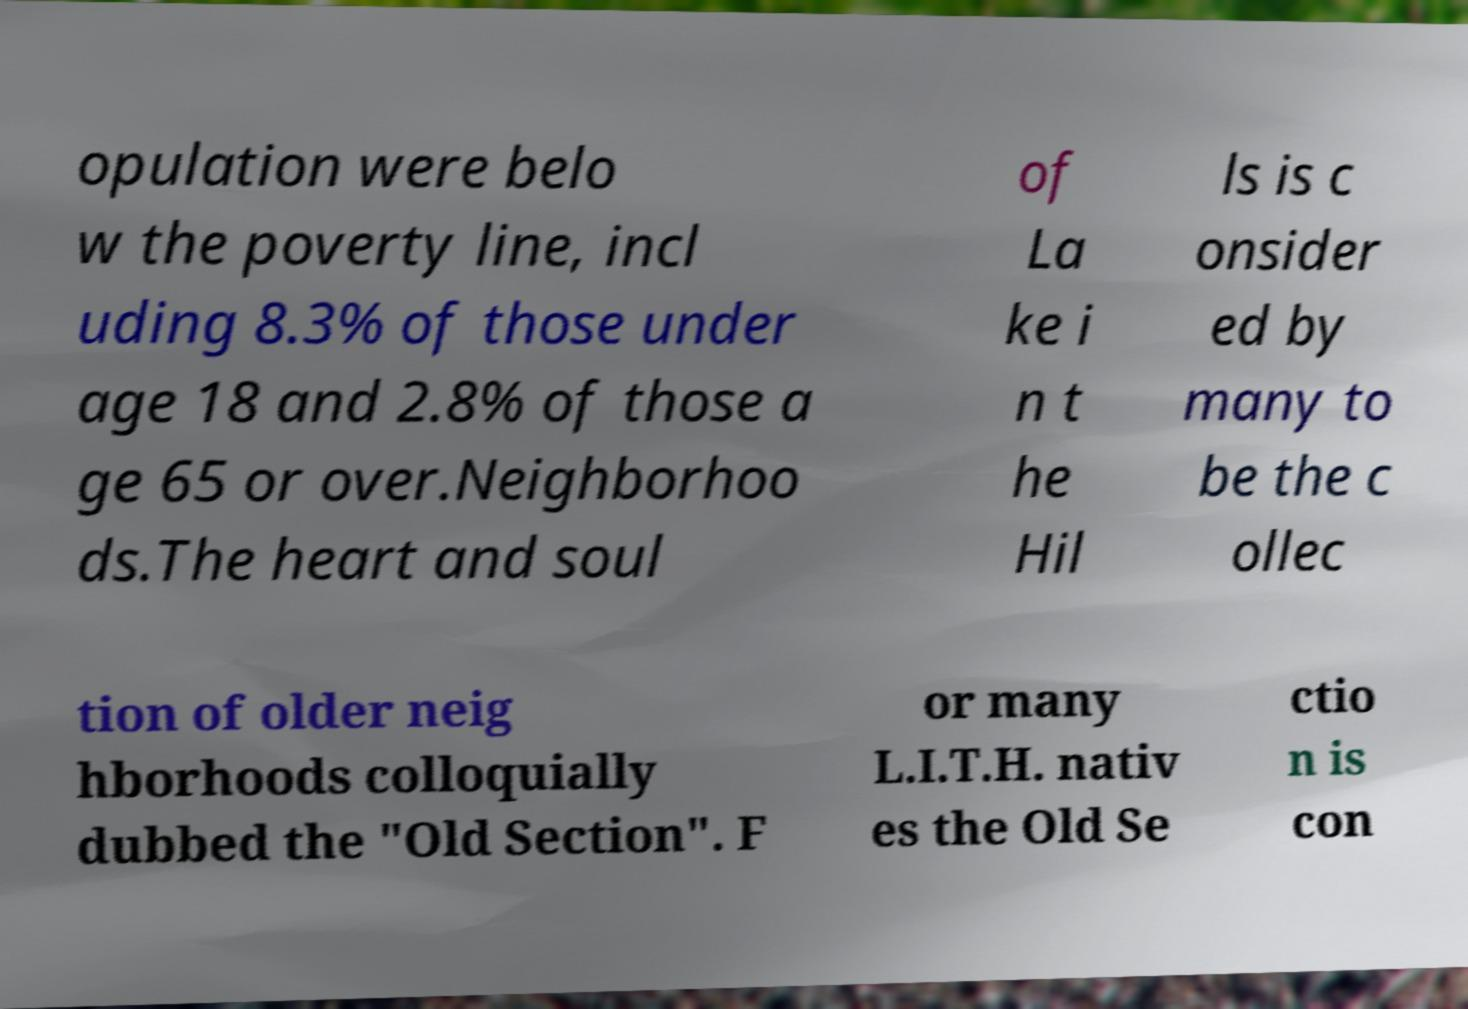For documentation purposes, I need the text within this image transcribed. Could you provide that? opulation were belo w the poverty line, incl uding 8.3% of those under age 18 and 2.8% of those a ge 65 or over.Neighborhoo ds.The heart and soul of La ke i n t he Hil ls is c onsider ed by many to be the c ollec tion of older neig hborhoods colloquially dubbed the "Old Section". F or many L.I.T.H. nativ es the Old Se ctio n is con 